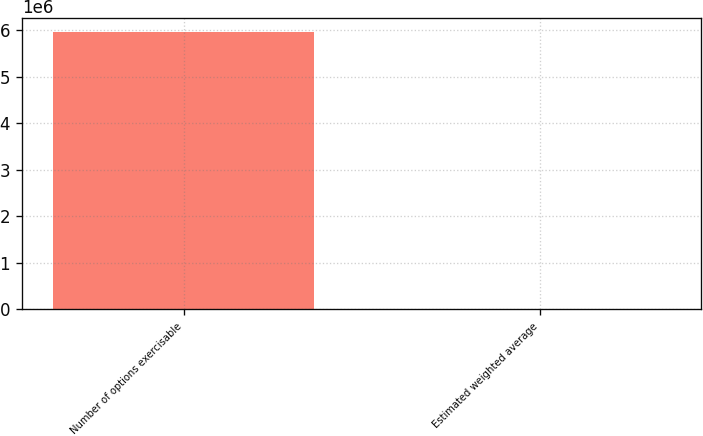Convert chart to OTSL. <chart><loc_0><loc_0><loc_500><loc_500><bar_chart><fcel>Number of options exercisable<fcel>Estimated weighted average<nl><fcel>5.95801e+06<fcel>17.94<nl></chart> 